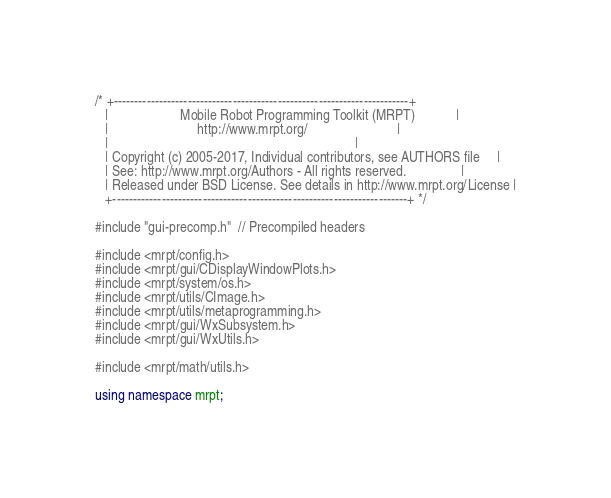Convert code to text. <code><loc_0><loc_0><loc_500><loc_500><_C++_>/* +------------------------------------------------------------------------+
   |                     Mobile Robot Programming Toolkit (MRPT)            |
   |                          http://www.mrpt.org/                          |
   |                                                                        |
   | Copyright (c) 2005-2017, Individual contributors, see AUTHORS file     |
   | See: http://www.mrpt.org/Authors - All rights reserved.                |
   | Released under BSD License. See details in http://www.mrpt.org/License |
   +------------------------------------------------------------------------+ */

#include "gui-precomp.h"  // Precompiled headers

#include <mrpt/config.h>
#include <mrpt/gui/CDisplayWindowPlots.h>
#include <mrpt/system/os.h>
#include <mrpt/utils/CImage.h>
#include <mrpt/utils/metaprogramming.h>
#include <mrpt/gui/WxSubsystem.h>
#include <mrpt/gui/WxUtils.h>

#include <mrpt/math/utils.h>

using namespace mrpt;</code> 